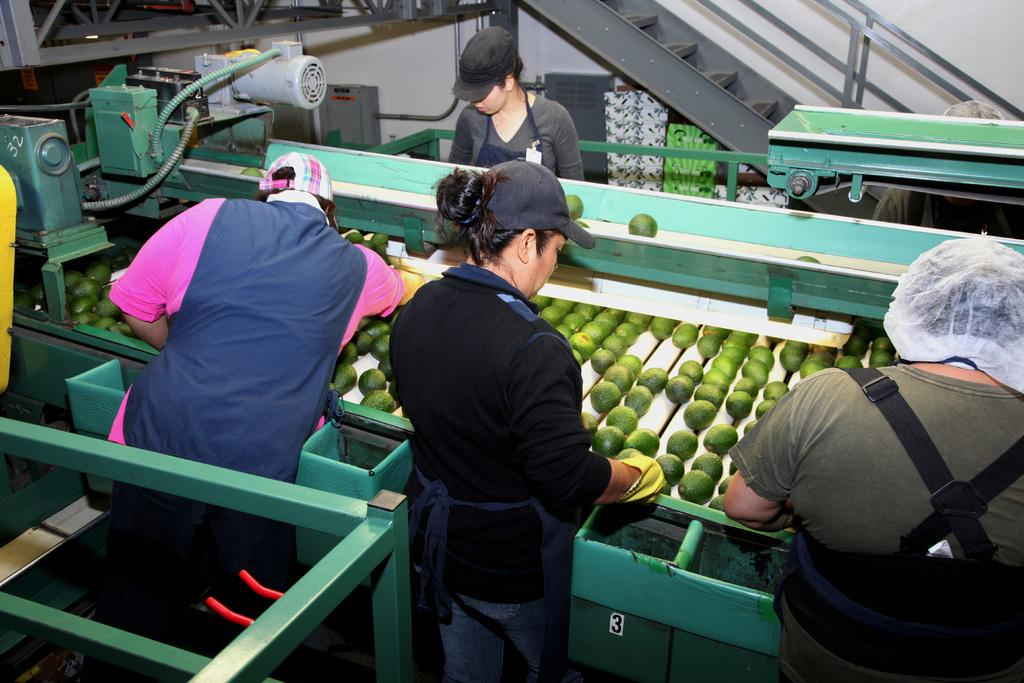How many people are in the image? There are four persons in the image. What can be seen in the image besides the people? There is a green-colored machine in the image, and fruits are kept on the machine. What is the color of the machine? The machine is green-colored. What is visible in the background of the image? There are steps in the background of the image. What is located to the left of the image? There is a motor to the left of the image. What is the name of the daughter of the person standing on the right in the image? A: There is no information about a daughter or any names in the image, so this question cannot be answered definitively. 